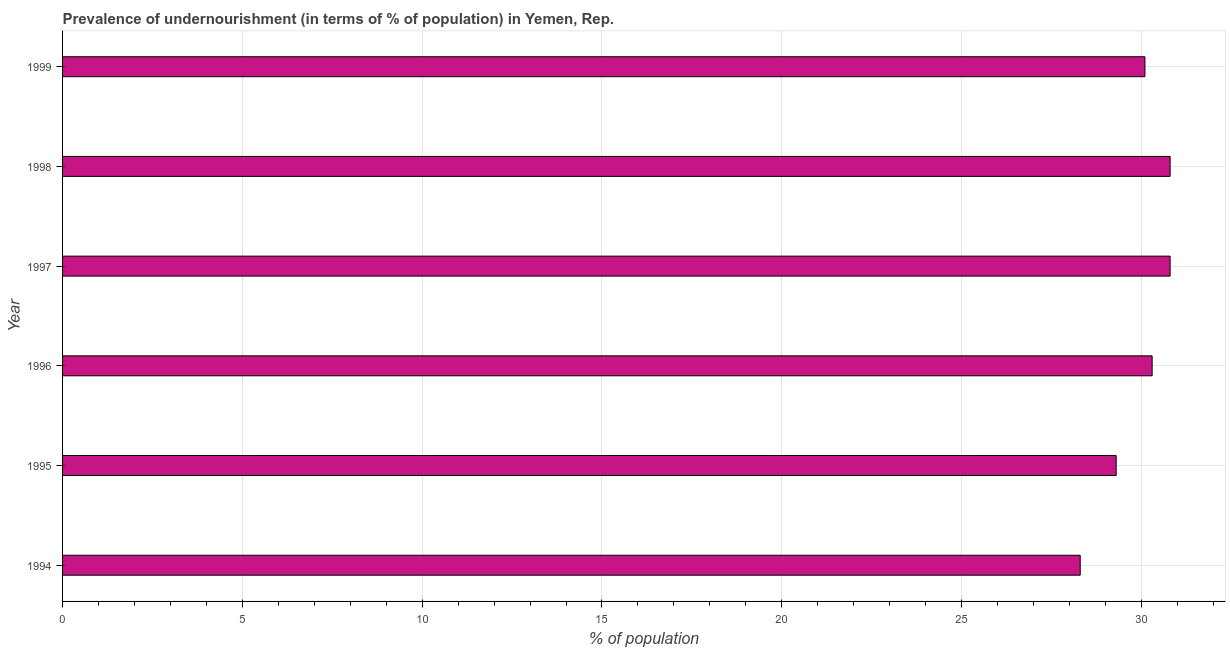Does the graph contain any zero values?
Provide a short and direct response. No. What is the title of the graph?
Provide a succinct answer. Prevalence of undernourishment (in terms of % of population) in Yemen, Rep. What is the label or title of the X-axis?
Your response must be concise. % of population. What is the label or title of the Y-axis?
Offer a terse response. Year. What is the percentage of undernourished population in 1996?
Offer a terse response. 30.3. Across all years, what is the maximum percentage of undernourished population?
Your answer should be compact. 30.8. Across all years, what is the minimum percentage of undernourished population?
Your answer should be compact. 28.3. In which year was the percentage of undernourished population minimum?
Provide a succinct answer. 1994. What is the sum of the percentage of undernourished population?
Keep it short and to the point. 179.6. What is the average percentage of undernourished population per year?
Provide a short and direct response. 29.93. What is the median percentage of undernourished population?
Offer a very short reply. 30.2. In how many years, is the percentage of undernourished population greater than 20 %?
Offer a terse response. 6. Do a majority of the years between 1999 and 1994 (inclusive) have percentage of undernourished population greater than 28 %?
Ensure brevity in your answer.  Yes. Is the difference between the percentage of undernourished population in 1994 and 1998 greater than the difference between any two years?
Offer a terse response. Yes. What is the difference between the highest and the second highest percentage of undernourished population?
Offer a very short reply. 0. Is the sum of the percentage of undernourished population in 1996 and 1997 greater than the maximum percentage of undernourished population across all years?
Make the answer very short. Yes. In how many years, is the percentage of undernourished population greater than the average percentage of undernourished population taken over all years?
Offer a terse response. 4. What is the difference between two consecutive major ticks on the X-axis?
Make the answer very short. 5. What is the % of population in 1994?
Provide a succinct answer. 28.3. What is the % of population of 1995?
Your answer should be very brief. 29.3. What is the % of population of 1996?
Offer a terse response. 30.3. What is the % of population of 1997?
Provide a succinct answer. 30.8. What is the % of population in 1998?
Provide a short and direct response. 30.8. What is the % of population in 1999?
Offer a terse response. 30.1. What is the difference between the % of population in 1994 and 1997?
Offer a very short reply. -2.5. What is the difference between the % of population in 1996 and 1997?
Offer a terse response. -0.5. What is the difference between the % of population in 1996 and 1998?
Offer a very short reply. -0.5. What is the difference between the % of population in 1998 and 1999?
Ensure brevity in your answer.  0.7. What is the ratio of the % of population in 1994 to that in 1995?
Offer a very short reply. 0.97. What is the ratio of the % of population in 1994 to that in 1996?
Give a very brief answer. 0.93. What is the ratio of the % of population in 1994 to that in 1997?
Offer a terse response. 0.92. What is the ratio of the % of population in 1994 to that in 1998?
Provide a succinct answer. 0.92. What is the ratio of the % of population in 1995 to that in 1997?
Give a very brief answer. 0.95. What is the ratio of the % of population in 1995 to that in 1998?
Your answer should be very brief. 0.95. What is the ratio of the % of population in 1995 to that in 1999?
Your answer should be very brief. 0.97. What is the ratio of the % of population in 1996 to that in 1997?
Your response must be concise. 0.98. What is the ratio of the % of population in 1996 to that in 1999?
Offer a terse response. 1.01. 